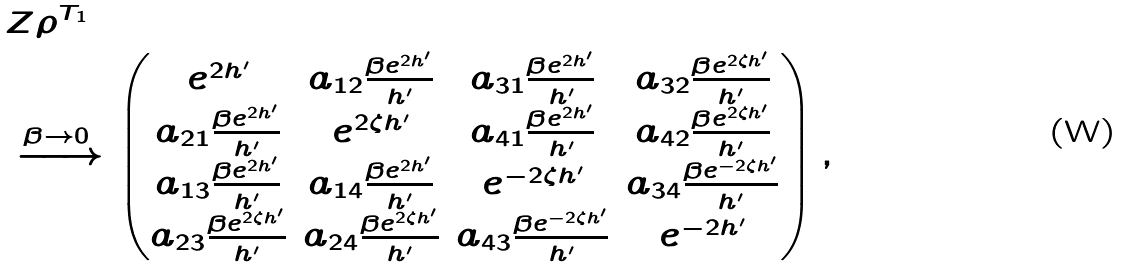<formula> <loc_0><loc_0><loc_500><loc_500>& Z \rho ^ { T _ { 1 } } \\ & \xrightarrow { \beta \rightarrow 0 } \begin{pmatrix} e ^ { 2 h ^ { \prime } } & a _ { 1 2 } \frac { \beta e ^ { 2 h ^ { \prime } } } { h ^ { \prime } } & a _ { 3 1 } \frac { \beta e ^ { 2 h ^ { \prime } } } { h ^ { \prime } } & a _ { 3 2 } \frac { \beta e ^ { 2 \zeta h ^ { \prime } } } { h ^ { \prime } } \\ a _ { 2 1 } \frac { \beta e ^ { 2 h ^ { \prime } } } { h ^ { \prime } } & e ^ { 2 \zeta h ^ { \prime } } & a _ { 4 1 } \frac { \beta e ^ { 2 h ^ { \prime } } } { h ^ { \prime } } & a _ { 4 2 } \frac { \beta e ^ { 2 \zeta h ^ { \prime } } } { h ^ { \prime } } \\ a _ { 1 3 } \frac { \beta e ^ { 2 h ^ { \prime } } } { h ^ { \prime } } & a _ { 1 4 } \frac { \beta e ^ { 2 h ^ { \prime } } } { h ^ { \prime } } & e ^ { - 2 \zeta h ^ { \prime } } & a _ { 3 4 } \frac { \beta e ^ { - 2 \zeta h ^ { \prime } } } { h ^ { \prime } } \\ a _ { 2 3 } \frac { \beta e ^ { 2 \zeta h ^ { \prime } } } { h ^ { \prime } } & a _ { 2 4 } \frac { \beta e ^ { 2 \zeta h ^ { \prime } } } { h ^ { \prime } } & a _ { 4 3 } \frac { \beta e ^ { - 2 \zeta h ^ { \prime } } } { h ^ { \prime } } & e ^ { - 2 h ^ { \prime } } \end{pmatrix} ,</formula> 